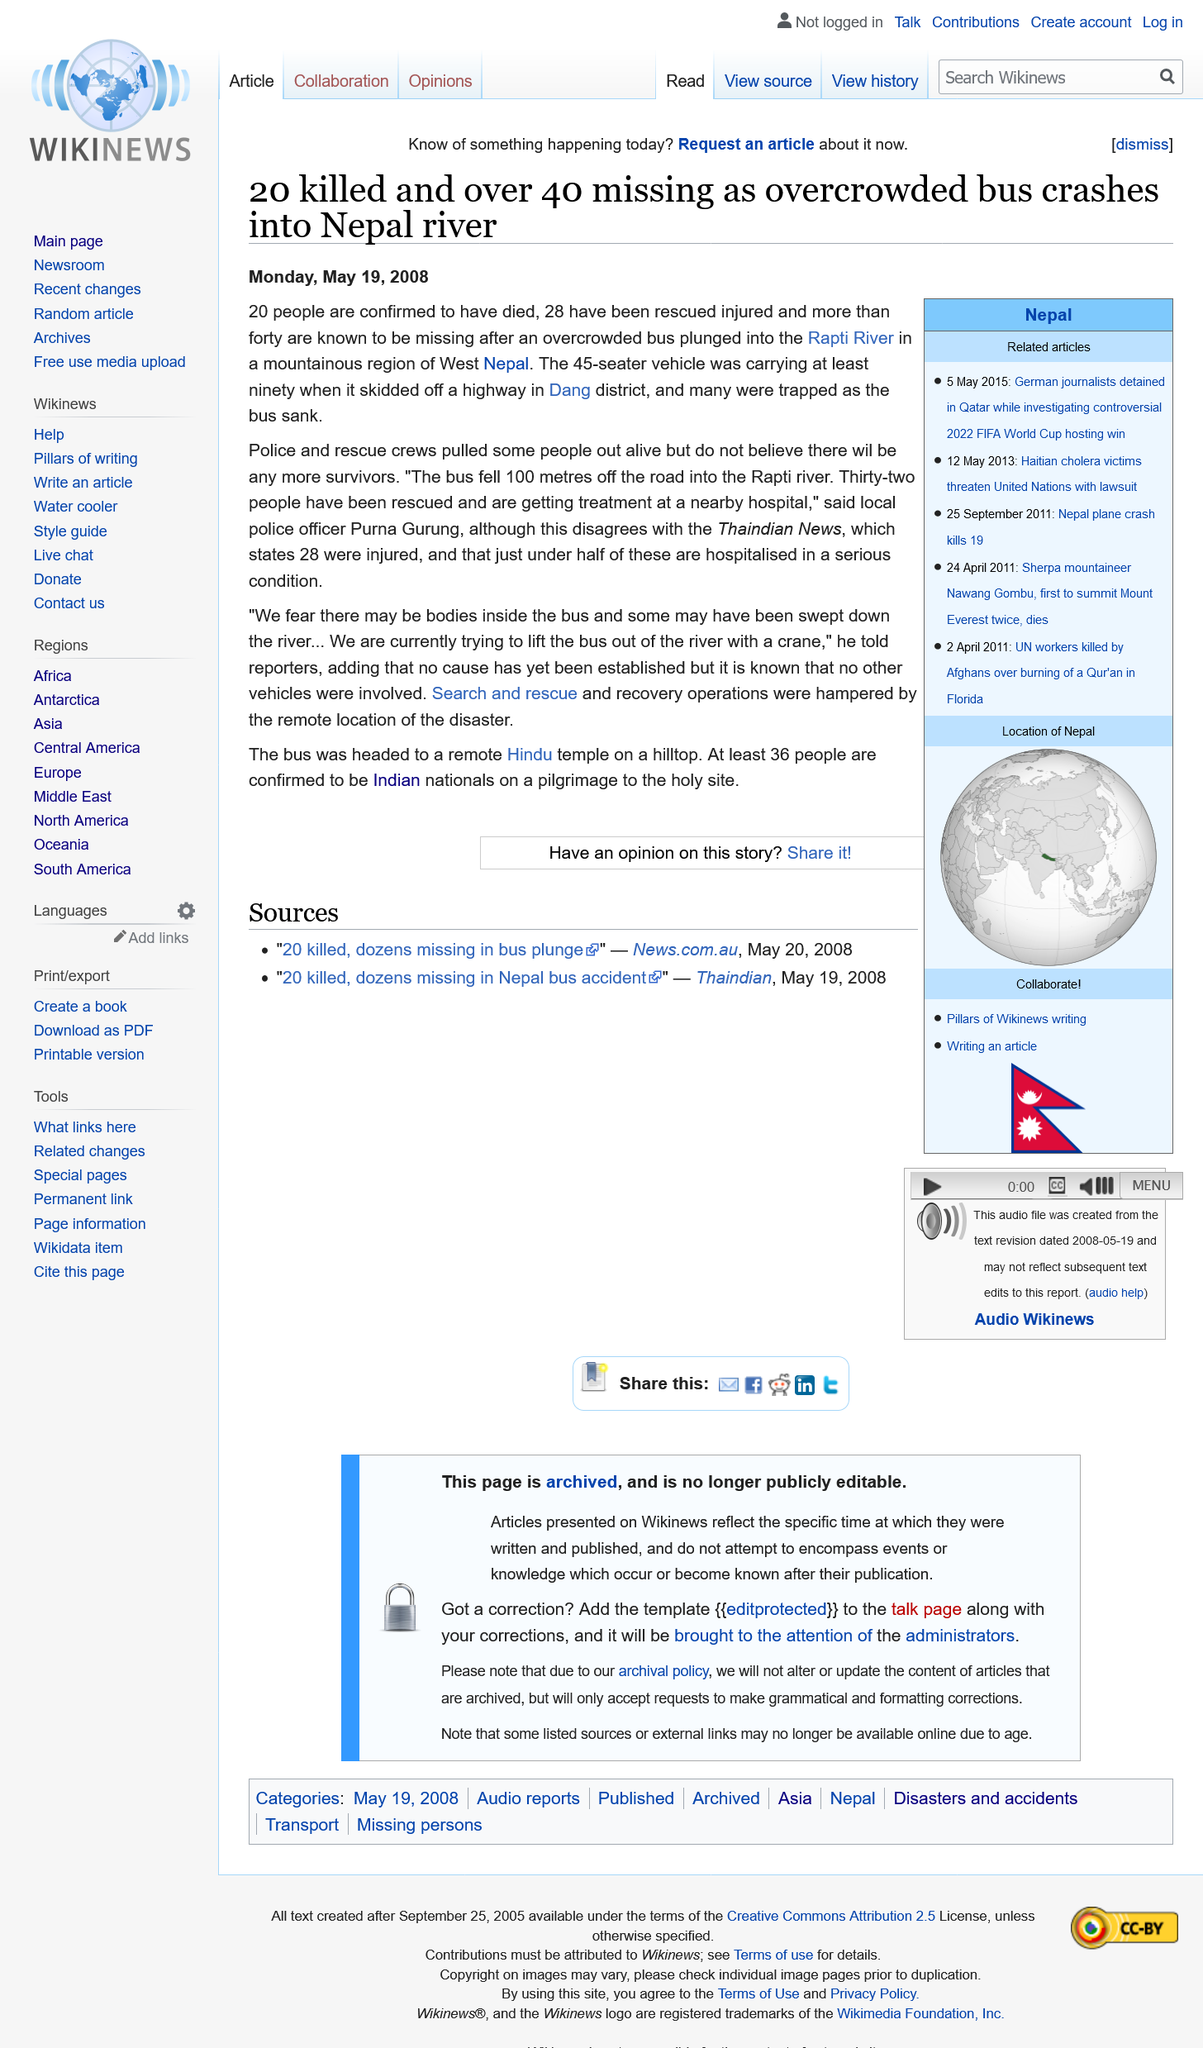Point out several critical features in this image. No cause has yet been established for the accident. The bus fell 100 meters into the river. In Nepal in 2008, a bus fell into the Rapti River. 